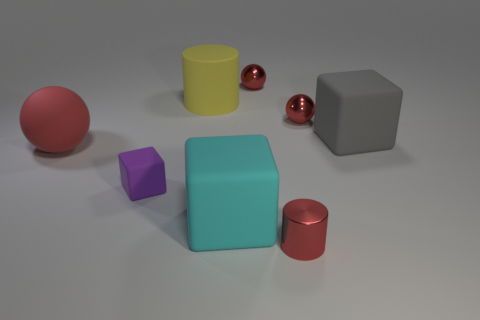The yellow matte cylinder is what size?
Provide a succinct answer. Large. Is the number of cylinders that are to the right of the yellow object greater than the number of big cyan cubes?
Give a very brief answer. No. Is there anything else that is the same material as the large gray thing?
Provide a short and direct response. Yes. There is a cylinder behind the big gray object; does it have the same color as the sphere that is left of the yellow rubber cylinder?
Keep it short and to the point. No. What is the big block that is on the left side of the rubber cube right of the small red ball to the right of the tiny cylinder made of?
Offer a terse response. Rubber. Is the number of cyan matte cubes greater than the number of big red metallic cubes?
Your answer should be very brief. Yes. Are there any other things that are the same color as the big sphere?
Give a very brief answer. Yes. There is a red sphere that is the same material as the purple cube; what size is it?
Make the answer very short. Large. What is the material of the large gray object?
Provide a short and direct response. Rubber. How many blocks are the same size as the cyan object?
Keep it short and to the point. 1. 